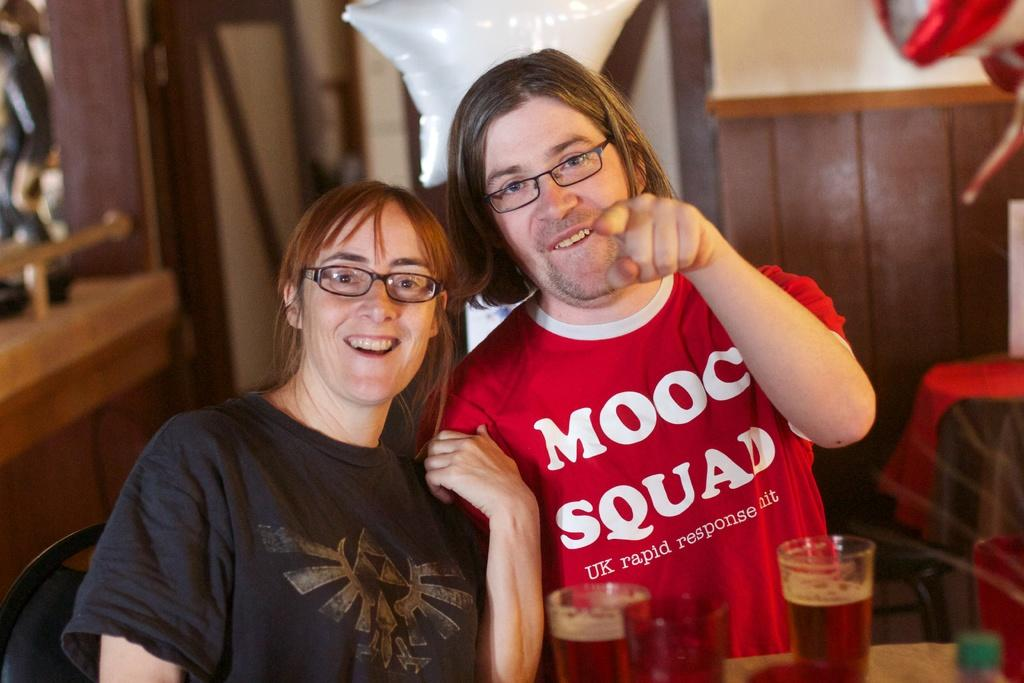How many people are in the image? There are two persons in the image. What are the persons doing in the image? The persons are smiling. What are the persons wearing in the image? The persons are wearing spectacles. What can be seen on the table in the image? There are glasses with a drink on the table. What type of furniture is present in the image? There are chairs and tables in the image. What other objects can be seen in the image? There are other objects in the image, but their specific details are not mentioned in the provided facts. Can you tell me how many snails are crawling on the coast in the image? There are no snails or coast visible in the image; it features two persons smiling and wearing spectacles, along with glasses with a drink, chairs, and tables. 